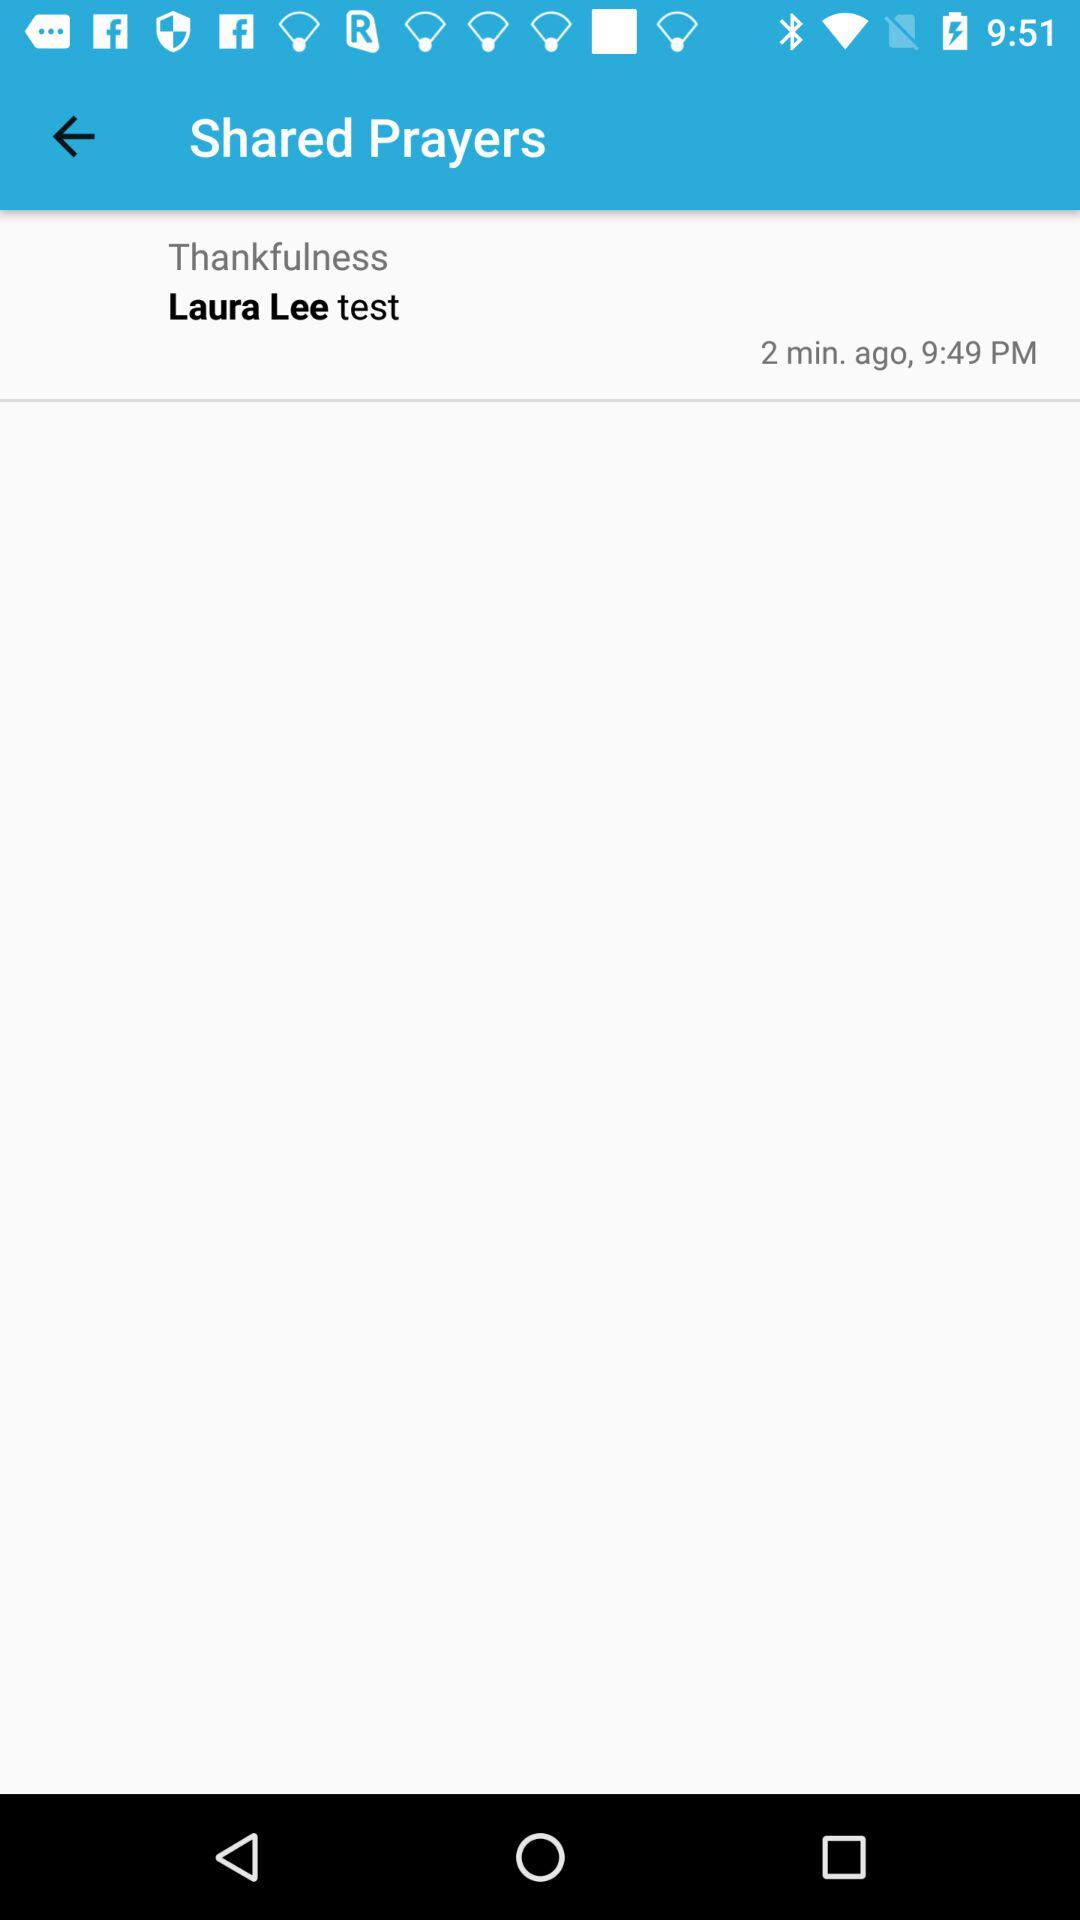How many minutes ago was the prayer shared?
Answer the question using a single word or phrase. 2 